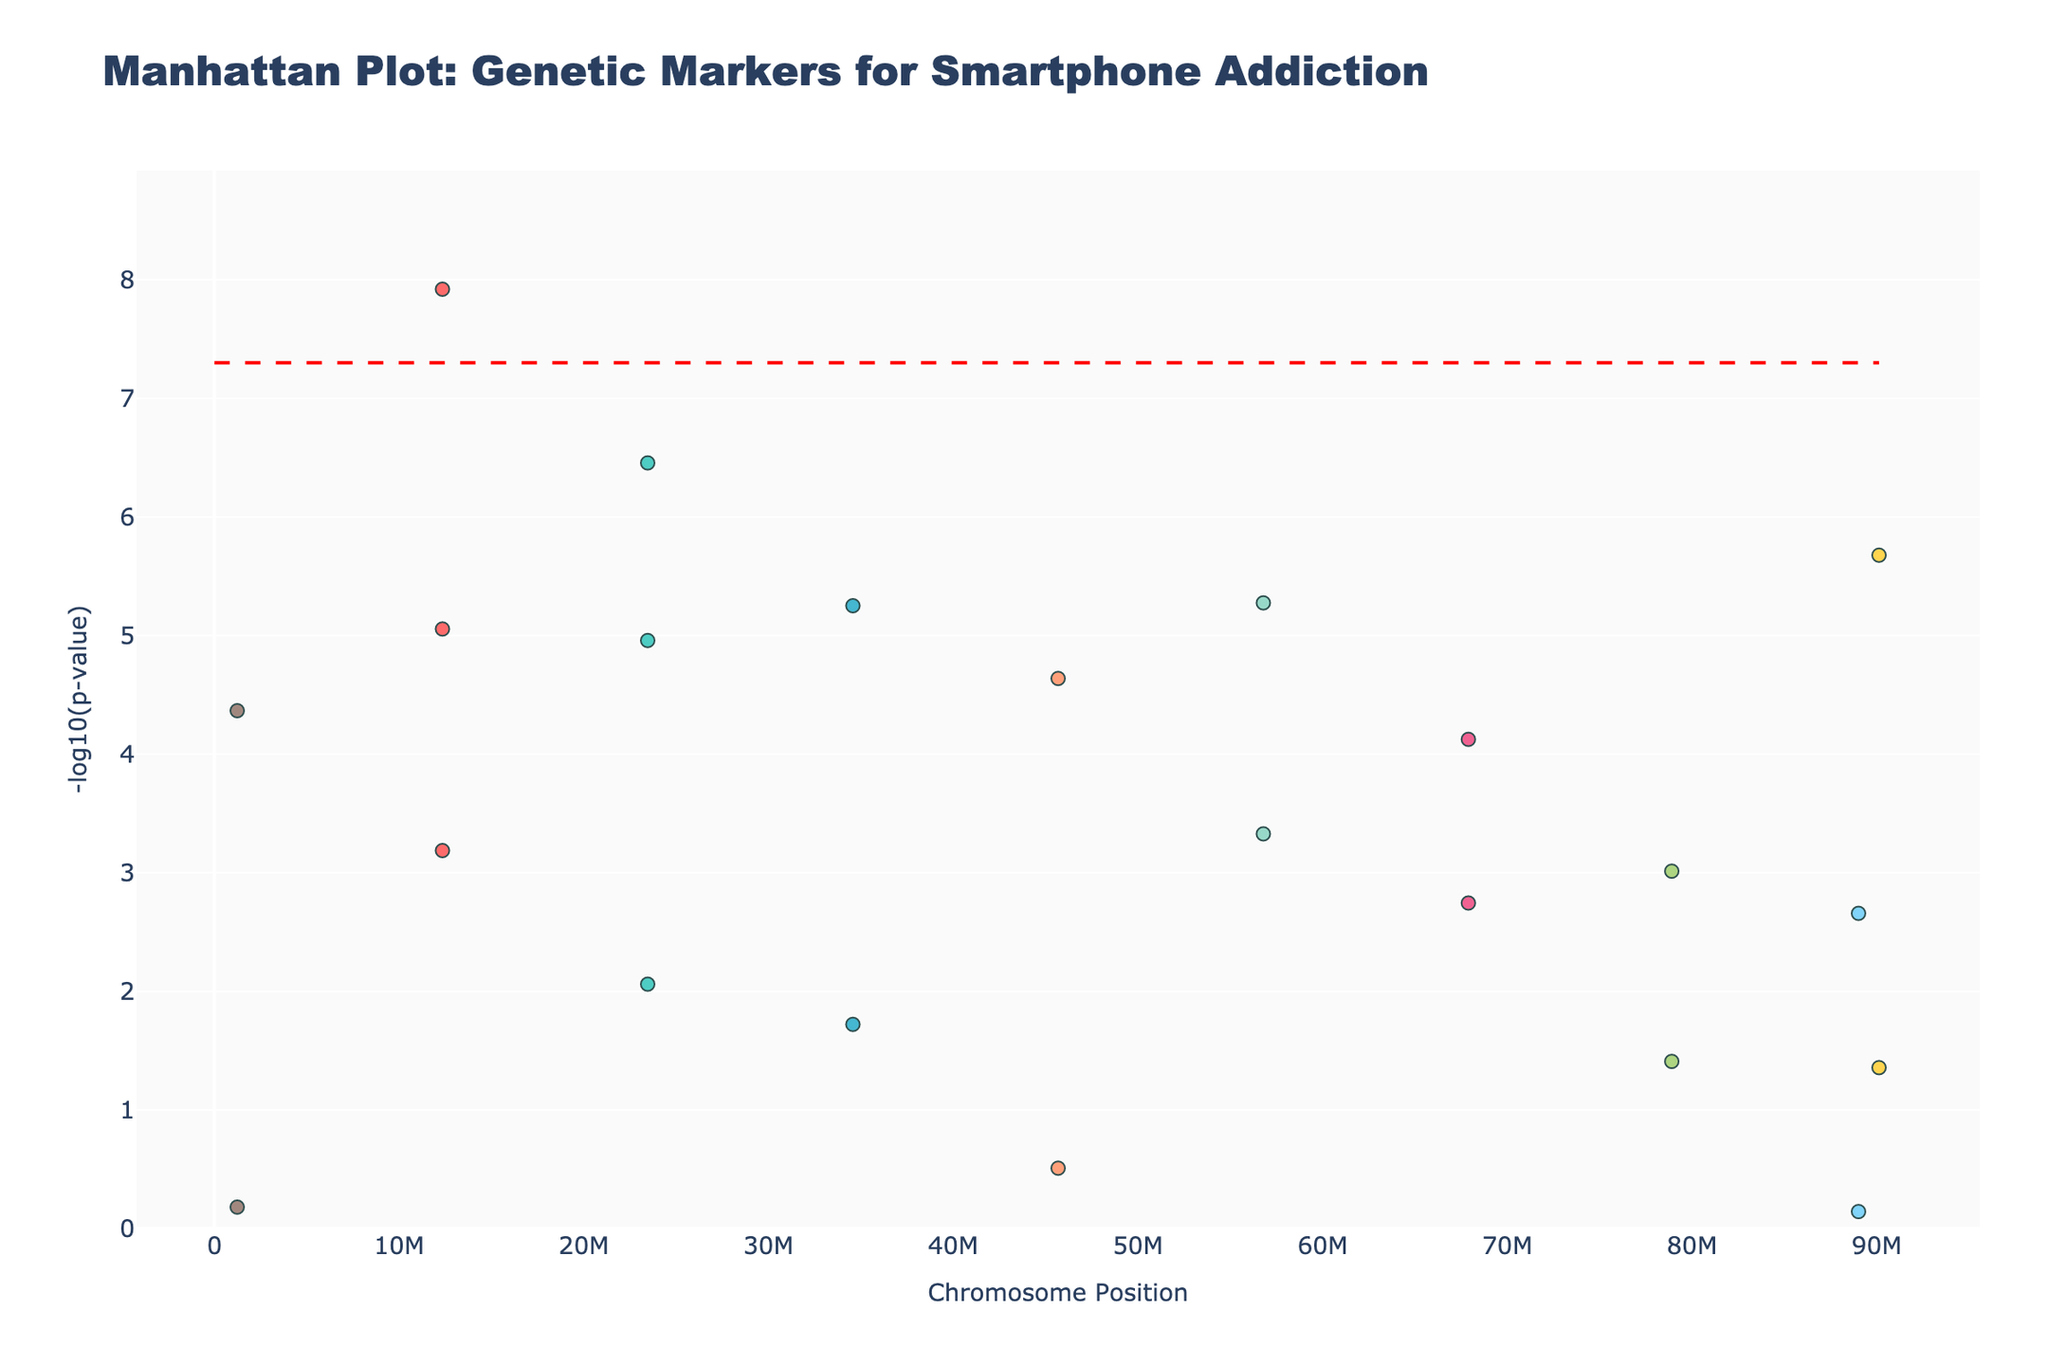Which chromosome has the highest -log10(p-value)? To determine the chromosome with the highest -log10(p-value), look for the highest point on the y-axis. According to the given data, the SNP rs1234567 on chromosome 1 has the highest observed value.
Answer: Chromosome 1 What is the title of the figure? The title is typically found at the top of the plot and indicates what the figure is about. In this case, it is stated in the code provided.
Answer: Manhattan Plot: Genetic Markers for Smartphone Addiction How many SNPs are represented on chromosome 3? To find the number of SNPs on chromosome 3, check for distinct data points on the x-axis for chromosome 3. Based on the provided data, there is one SNP (rs3456789) on chromosome 3.
Answer: 1 Which SNP has a p-value less than 5e-8? A p-value less than 5e-8 corresponds to a -log10(p-value) greater than 7. Check the data points that exceed this threshold. The SNP rs1234567 on chromosome 1 meets this condition.
Answer: rs1234567 Compare the -log10(p-value) of SNPs rs6789012 and rs7890123. Which is larger? First, identify the -log10(p-value) for both SNPs. For rs6789012, it is -log10(1.8e-3). For rs7890123, it is -log10(3.9e-2). Calculate the values and compare. -log10(1.8e-3) is larger than -log10(3.9e-2).
Answer: rs6789012 What is the y-axis title of the Manhattan Plot? The y-axis title is found along the vertical axis and describes what is being measured. From the code, it is explicitly stated.
Answer: -log10(p-value) How many SNPs have a -log10(p-value) greater than 5? This requires counting the SNPs where the -log10(p-value) exceeds 5. Based on the transformed p-values, there are multiple SNPs that meet this threshold: rs1234567, rs2345678, rs9012345, rs1234567, rs2345678, and rs5678901.
Answer: 6 Which chromosome positions are associated with the gene NRXN1? Locate the SNP associated with the gene NRXN1 in the data and identify its chromosome position. From the data, NRXN1 is associated with chromosome 1 at position 12345678.
Answer: 12345678 